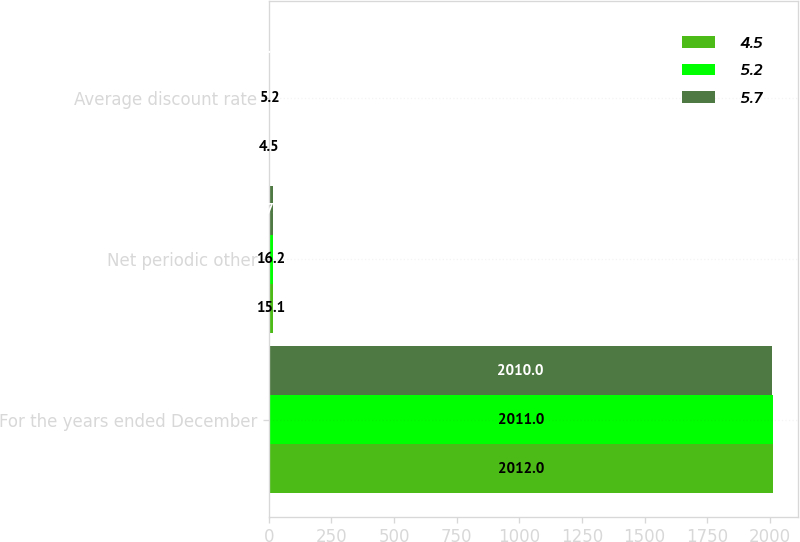<chart> <loc_0><loc_0><loc_500><loc_500><stacked_bar_chart><ecel><fcel>For the years ended December<fcel>Net periodic other<fcel>Average discount rate<nl><fcel>4.5<fcel>2012<fcel>15.1<fcel>4.5<nl><fcel>5.2<fcel>2011<fcel>16.2<fcel>5.2<nl><fcel>5.7<fcel>2010<fcel>17.5<fcel>5.7<nl></chart> 